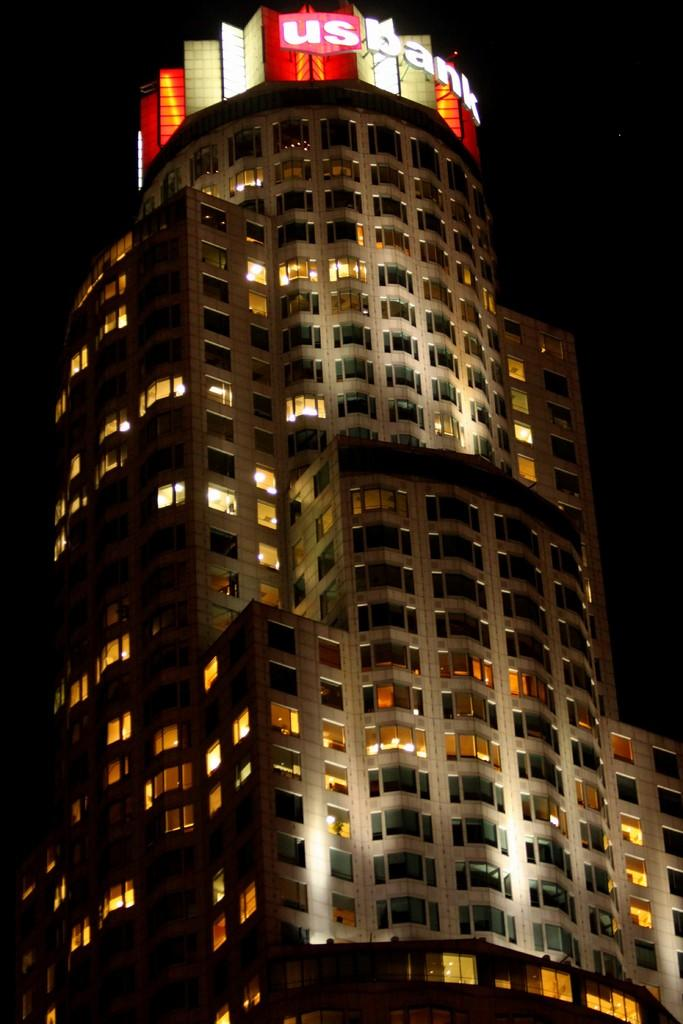What type of structure is visible in the image? There is a building in the image. What object can be seen in front of the building? There is a board in the image. How would you describe the overall lighting in the image? The background of the image is dark. Can you tell me how many bottles are on the board in the image? There is no bottle present on the board or in the image. What does the aunt say about the building in the image? There is no mention of an aunt or any dialogue in the image. 